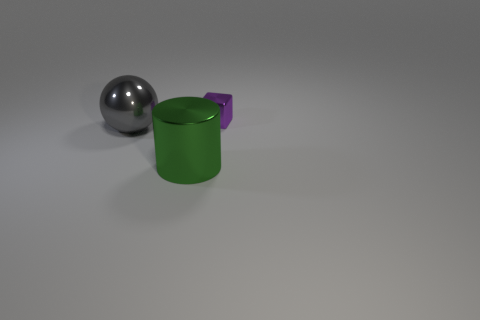What is the shape of the big green thing that is the same material as the small object?
Offer a very short reply. Cylinder. Is there a small metal block of the same color as the big cylinder?
Ensure brevity in your answer.  No. What number of matte things are spheres or tiny things?
Offer a very short reply. 0. How many tiny purple cubes are right of the large metallic object in front of the gray metal object?
Offer a terse response. 1. How many large green objects have the same material as the large gray ball?
Keep it short and to the point. 1. What number of large objects are gray blocks or metallic blocks?
Make the answer very short. 0. There is a object that is both right of the shiny ball and behind the big green shiny cylinder; what shape is it?
Your answer should be very brief. Cube. Is the big green cylinder made of the same material as the purple object?
Provide a succinct answer. Yes. There is a cylinder that is the same size as the gray metal object; what color is it?
Keep it short and to the point. Green. There is a thing that is in front of the tiny purple shiny object and behind the green metal thing; what is its color?
Keep it short and to the point. Gray. 